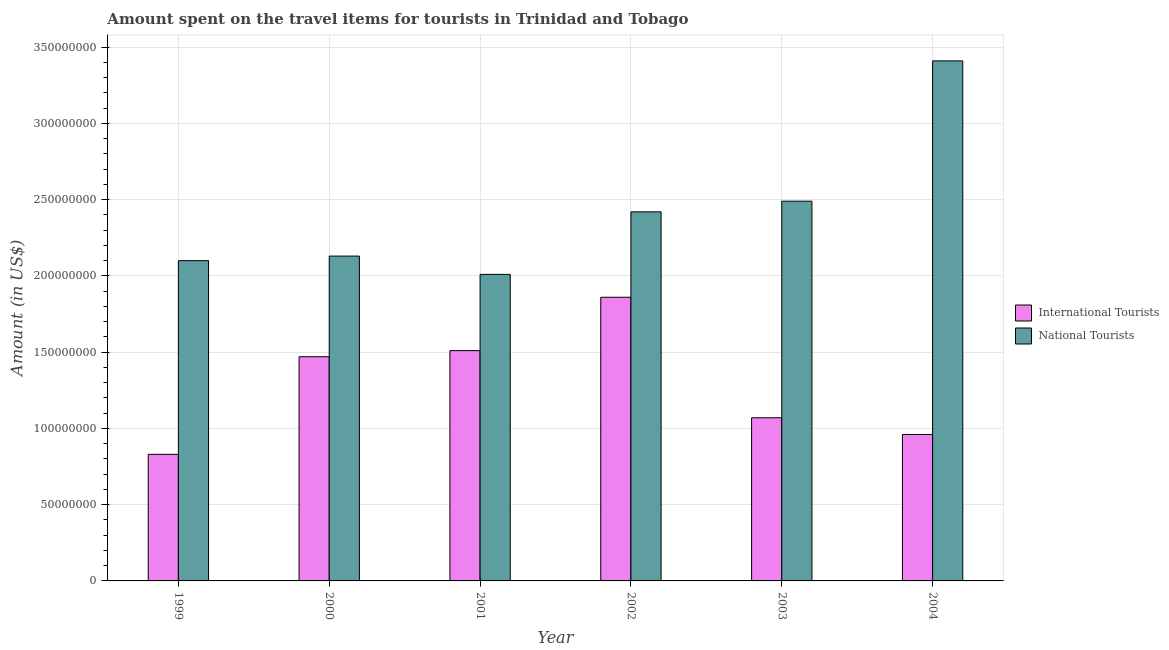Are the number of bars on each tick of the X-axis equal?
Ensure brevity in your answer.  Yes. How many bars are there on the 1st tick from the left?
Offer a very short reply. 2. What is the amount spent on travel items of national tourists in 2002?
Offer a very short reply. 2.42e+08. Across all years, what is the maximum amount spent on travel items of international tourists?
Offer a terse response. 1.86e+08. Across all years, what is the minimum amount spent on travel items of national tourists?
Give a very brief answer. 2.01e+08. What is the total amount spent on travel items of international tourists in the graph?
Your response must be concise. 7.70e+08. What is the difference between the amount spent on travel items of national tourists in 2000 and that in 2002?
Ensure brevity in your answer.  -2.90e+07. What is the difference between the amount spent on travel items of national tourists in 2001 and the amount spent on travel items of international tourists in 2002?
Your answer should be very brief. -4.10e+07. What is the average amount spent on travel items of international tourists per year?
Provide a short and direct response. 1.28e+08. In the year 2003, what is the difference between the amount spent on travel items of national tourists and amount spent on travel items of international tourists?
Ensure brevity in your answer.  0. What is the ratio of the amount spent on travel items of national tourists in 2000 to that in 2001?
Make the answer very short. 1.06. What is the difference between the highest and the second highest amount spent on travel items of international tourists?
Make the answer very short. 3.50e+07. What is the difference between the highest and the lowest amount spent on travel items of national tourists?
Offer a terse response. 1.40e+08. In how many years, is the amount spent on travel items of international tourists greater than the average amount spent on travel items of international tourists taken over all years?
Provide a short and direct response. 3. What does the 2nd bar from the left in 2000 represents?
Ensure brevity in your answer.  National Tourists. What does the 1st bar from the right in 2004 represents?
Provide a succinct answer. National Tourists. How many bars are there?
Your answer should be very brief. 12. What is the difference between two consecutive major ticks on the Y-axis?
Your answer should be compact. 5.00e+07. Are the values on the major ticks of Y-axis written in scientific E-notation?
Provide a succinct answer. No. Does the graph contain any zero values?
Ensure brevity in your answer.  No. Does the graph contain grids?
Give a very brief answer. Yes. What is the title of the graph?
Provide a succinct answer. Amount spent on the travel items for tourists in Trinidad and Tobago. Does "Male entrants" appear as one of the legend labels in the graph?
Provide a succinct answer. No. What is the Amount (in US$) in International Tourists in 1999?
Provide a succinct answer. 8.30e+07. What is the Amount (in US$) of National Tourists in 1999?
Offer a very short reply. 2.10e+08. What is the Amount (in US$) of International Tourists in 2000?
Your answer should be very brief. 1.47e+08. What is the Amount (in US$) in National Tourists in 2000?
Keep it short and to the point. 2.13e+08. What is the Amount (in US$) in International Tourists in 2001?
Provide a succinct answer. 1.51e+08. What is the Amount (in US$) of National Tourists in 2001?
Offer a terse response. 2.01e+08. What is the Amount (in US$) in International Tourists in 2002?
Your answer should be compact. 1.86e+08. What is the Amount (in US$) in National Tourists in 2002?
Offer a very short reply. 2.42e+08. What is the Amount (in US$) in International Tourists in 2003?
Your answer should be compact. 1.07e+08. What is the Amount (in US$) of National Tourists in 2003?
Offer a very short reply. 2.49e+08. What is the Amount (in US$) in International Tourists in 2004?
Your answer should be compact. 9.60e+07. What is the Amount (in US$) in National Tourists in 2004?
Your answer should be compact. 3.41e+08. Across all years, what is the maximum Amount (in US$) in International Tourists?
Your answer should be compact. 1.86e+08. Across all years, what is the maximum Amount (in US$) of National Tourists?
Provide a short and direct response. 3.41e+08. Across all years, what is the minimum Amount (in US$) of International Tourists?
Offer a very short reply. 8.30e+07. Across all years, what is the minimum Amount (in US$) of National Tourists?
Your answer should be very brief. 2.01e+08. What is the total Amount (in US$) in International Tourists in the graph?
Ensure brevity in your answer.  7.70e+08. What is the total Amount (in US$) of National Tourists in the graph?
Your answer should be compact. 1.46e+09. What is the difference between the Amount (in US$) in International Tourists in 1999 and that in 2000?
Make the answer very short. -6.40e+07. What is the difference between the Amount (in US$) of International Tourists in 1999 and that in 2001?
Provide a short and direct response. -6.80e+07. What is the difference between the Amount (in US$) of National Tourists in 1999 and that in 2001?
Offer a terse response. 9.00e+06. What is the difference between the Amount (in US$) of International Tourists in 1999 and that in 2002?
Your answer should be compact. -1.03e+08. What is the difference between the Amount (in US$) in National Tourists in 1999 and that in 2002?
Your answer should be compact. -3.20e+07. What is the difference between the Amount (in US$) in International Tourists in 1999 and that in 2003?
Your answer should be very brief. -2.40e+07. What is the difference between the Amount (in US$) of National Tourists in 1999 and that in 2003?
Give a very brief answer. -3.90e+07. What is the difference between the Amount (in US$) in International Tourists in 1999 and that in 2004?
Offer a very short reply. -1.30e+07. What is the difference between the Amount (in US$) in National Tourists in 1999 and that in 2004?
Your answer should be very brief. -1.31e+08. What is the difference between the Amount (in US$) of National Tourists in 2000 and that in 2001?
Provide a succinct answer. 1.20e+07. What is the difference between the Amount (in US$) of International Tourists in 2000 and that in 2002?
Offer a very short reply. -3.90e+07. What is the difference between the Amount (in US$) in National Tourists in 2000 and that in 2002?
Your response must be concise. -2.90e+07. What is the difference between the Amount (in US$) in International Tourists in 2000 and that in 2003?
Your response must be concise. 4.00e+07. What is the difference between the Amount (in US$) of National Tourists in 2000 and that in 2003?
Keep it short and to the point. -3.60e+07. What is the difference between the Amount (in US$) in International Tourists in 2000 and that in 2004?
Give a very brief answer. 5.10e+07. What is the difference between the Amount (in US$) of National Tourists in 2000 and that in 2004?
Provide a succinct answer. -1.28e+08. What is the difference between the Amount (in US$) in International Tourists in 2001 and that in 2002?
Offer a very short reply. -3.50e+07. What is the difference between the Amount (in US$) of National Tourists in 2001 and that in 2002?
Keep it short and to the point. -4.10e+07. What is the difference between the Amount (in US$) of International Tourists in 2001 and that in 2003?
Your answer should be very brief. 4.40e+07. What is the difference between the Amount (in US$) in National Tourists in 2001 and that in 2003?
Your answer should be compact. -4.80e+07. What is the difference between the Amount (in US$) in International Tourists in 2001 and that in 2004?
Offer a very short reply. 5.50e+07. What is the difference between the Amount (in US$) of National Tourists in 2001 and that in 2004?
Your response must be concise. -1.40e+08. What is the difference between the Amount (in US$) of International Tourists in 2002 and that in 2003?
Ensure brevity in your answer.  7.90e+07. What is the difference between the Amount (in US$) in National Tourists in 2002 and that in 2003?
Your answer should be compact. -7.00e+06. What is the difference between the Amount (in US$) of International Tourists in 2002 and that in 2004?
Offer a terse response. 9.00e+07. What is the difference between the Amount (in US$) of National Tourists in 2002 and that in 2004?
Keep it short and to the point. -9.90e+07. What is the difference between the Amount (in US$) of International Tourists in 2003 and that in 2004?
Give a very brief answer. 1.10e+07. What is the difference between the Amount (in US$) in National Tourists in 2003 and that in 2004?
Offer a terse response. -9.20e+07. What is the difference between the Amount (in US$) of International Tourists in 1999 and the Amount (in US$) of National Tourists in 2000?
Make the answer very short. -1.30e+08. What is the difference between the Amount (in US$) in International Tourists in 1999 and the Amount (in US$) in National Tourists in 2001?
Offer a very short reply. -1.18e+08. What is the difference between the Amount (in US$) in International Tourists in 1999 and the Amount (in US$) in National Tourists in 2002?
Your answer should be very brief. -1.59e+08. What is the difference between the Amount (in US$) in International Tourists in 1999 and the Amount (in US$) in National Tourists in 2003?
Provide a short and direct response. -1.66e+08. What is the difference between the Amount (in US$) of International Tourists in 1999 and the Amount (in US$) of National Tourists in 2004?
Keep it short and to the point. -2.58e+08. What is the difference between the Amount (in US$) in International Tourists in 2000 and the Amount (in US$) in National Tourists in 2001?
Offer a very short reply. -5.40e+07. What is the difference between the Amount (in US$) of International Tourists in 2000 and the Amount (in US$) of National Tourists in 2002?
Give a very brief answer. -9.50e+07. What is the difference between the Amount (in US$) in International Tourists in 2000 and the Amount (in US$) in National Tourists in 2003?
Keep it short and to the point. -1.02e+08. What is the difference between the Amount (in US$) of International Tourists in 2000 and the Amount (in US$) of National Tourists in 2004?
Give a very brief answer. -1.94e+08. What is the difference between the Amount (in US$) of International Tourists in 2001 and the Amount (in US$) of National Tourists in 2002?
Provide a succinct answer. -9.10e+07. What is the difference between the Amount (in US$) in International Tourists in 2001 and the Amount (in US$) in National Tourists in 2003?
Offer a terse response. -9.80e+07. What is the difference between the Amount (in US$) of International Tourists in 2001 and the Amount (in US$) of National Tourists in 2004?
Your answer should be very brief. -1.90e+08. What is the difference between the Amount (in US$) of International Tourists in 2002 and the Amount (in US$) of National Tourists in 2003?
Ensure brevity in your answer.  -6.30e+07. What is the difference between the Amount (in US$) in International Tourists in 2002 and the Amount (in US$) in National Tourists in 2004?
Ensure brevity in your answer.  -1.55e+08. What is the difference between the Amount (in US$) of International Tourists in 2003 and the Amount (in US$) of National Tourists in 2004?
Offer a very short reply. -2.34e+08. What is the average Amount (in US$) of International Tourists per year?
Your answer should be compact. 1.28e+08. What is the average Amount (in US$) of National Tourists per year?
Give a very brief answer. 2.43e+08. In the year 1999, what is the difference between the Amount (in US$) of International Tourists and Amount (in US$) of National Tourists?
Give a very brief answer. -1.27e+08. In the year 2000, what is the difference between the Amount (in US$) of International Tourists and Amount (in US$) of National Tourists?
Provide a succinct answer. -6.60e+07. In the year 2001, what is the difference between the Amount (in US$) in International Tourists and Amount (in US$) in National Tourists?
Make the answer very short. -5.00e+07. In the year 2002, what is the difference between the Amount (in US$) in International Tourists and Amount (in US$) in National Tourists?
Offer a very short reply. -5.60e+07. In the year 2003, what is the difference between the Amount (in US$) in International Tourists and Amount (in US$) in National Tourists?
Provide a short and direct response. -1.42e+08. In the year 2004, what is the difference between the Amount (in US$) in International Tourists and Amount (in US$) in National Tourists?
Make the answer very short. -2.45e+08. What is the ratio of the Amount (in US$) of International Tourists in 1999 to that in 2000?
Provide a succinct answer. 0.56. What is the ratio of the Amount (in US$) in National Tourists in 1999 to that in 2000?
Ensure brevity in your answer.  0.99. What is the ratio of the Amount (in US$) in International Tourists in 1999 to that in 2001?
Provide a succinct answer. 0.55. What is the ratio of the Amount (in US$) in National Tourists in 1999 to that in 2001?
Offer a terse response. 1.04. What is the ratio of the Amount (in US$) in International Tourists in 1999 to that in 2002?
Your answer should be very brief. 0.45. What is the ratio of the Amount (in US$) of National Tourists in 1999 to that in 2002?
Keep it short and to the point. 0.87. What is the ratio of the Amount (in US$) of International Tourists in 1999 to that in 2003?
Keep it short and to the point. 0.78. What is the ratio of the Amount (in US$) in National Tourists in 1999 to that in 2003?
Your answer should be compact. 0.84. What is the ratio of the Amount (in US$) of International Tourists in 1999 to that in 2004?
Offer a very short reply. 0.86. What is the ratio of the Amount (in US$) of National Tourists in 1999 to that in 2004?
Offer a terse response. 0.62. What is the ratio of the Amount (in US$) of International Tourists in 2000 to that in 2001?
Your answer should be compact. 0.97. What is the ratio of the Amount (in US$) in National Tourists in 2000 to that in 2001?
Give a very brief answer. 1.06. What is the ratio of the Amount (in US$) of International Tourists in 2000 to that in 2002?
Provide a short and direct response. 0.79. What is the ratio of the Amount (in US$) of National Tourists in 2000 to that in 2002?
Ensure brevity in your answer.  0.88. What is the ratio of the Amount (in US$) of International Tourists in 2000 to that in 2003?
Keep it short and to the point. 1.37. What is the ratio of the Amount (in US$) in National Tourists in 2000 to that in 2003?
Keep it short and to the point. 0.86. What is the ratio of the Amount (in US$) of International Tourists in 2000 to that in 2004?
Provide a succinct answer. 1.53. What is the ratio of the Amount (in US$) in National Tourists in 2000 to that in 2004?
Keep it short and to the point. 0.62. What is the ratio of the Amount (in US$) of International Tourists in 2001 to that in 2002?
Give a very brief answer. 0.81. What is the ratio of the Amount (in US$) of National Tourists in 2001 to that in 2002?
Your answer should be compact. 0.83. What is the ratio of the Amount (in US$) of International Tourists in 2001 to that in 2003?
Ensure brevity in your answer.  1.41. What is the ratio of the Amount (in US$) in National Tourists in 2001 to that in 2003?
Offer a terse response. 0.81. What is the ratio of the Amount (in US$) in International Tourists in 2001 to that in 2004?
Provide a succinct answer. 1.57. What is the ratio of the Amount (in US$) of National Tourists in 2001 to that in 2004?
Keep it short and to the point. 0.59. What is the ratio of the Amount (in US$) in International Tourists in 2002 to that in 2003?
Offer a very short reply. 1.74. What is the ratio of the Amount (in US$) in National Tourists in 2002 to that in 2003?
Provide a short and direct response. 0.97. What is the ratio of the Amount (in US$) of International Tourists in 2002 to that in 2004?
Keep it short and to the point. 1.94. What is the ratio of the Amount (in US$) in National Tourists in 2002 to that in 2004?
Provide a succinct answer. 0.71. What is the ratio of the Amount (in US$) in International Tourists in 2003 to that in 2004?
Offer a terse response. 1.11. What is the ratio of the Amount (in US$) of National Tourists in 2003 to that in 2004?
Make the answer very short. 0.73. What is the difference between the highest and the second highest Amount (in US$) in International Tourists?
Offer a very short reply. 3.50e+07. What is the difference between the highest and the second highest Amount (in US$) of National Tourists?
Make the answer very short. 9.20e+07. What is the difference between the highest and the lowest Amount (in US$) in International Tourists?
Your answer should be compact. 1.03e+08. What is the difference between the highest and the lowest Amount (in US$) of National Tourists?
Give a very brief answer. 1.40e+08. 